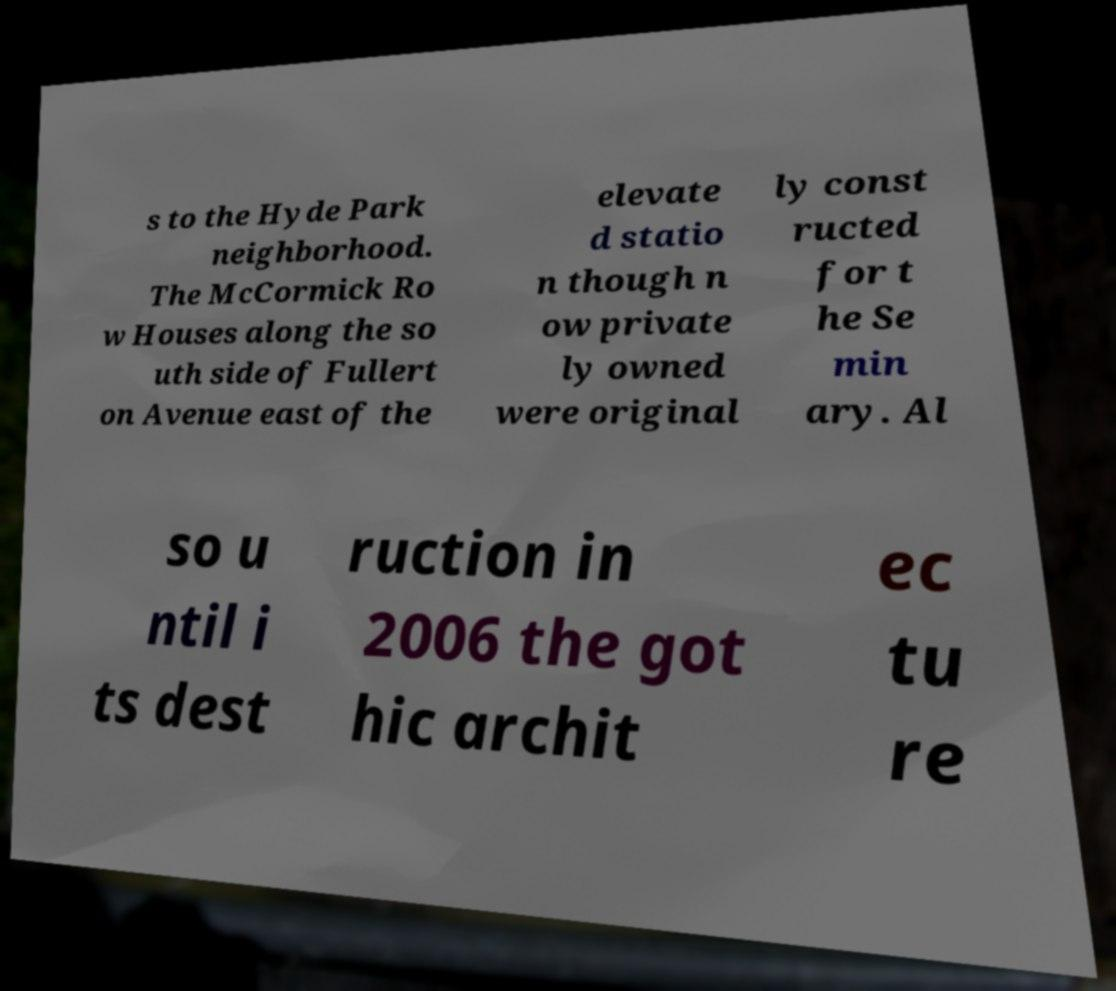What messages or text are displayed in this image? I need them in a readable, typed format. s to the Hyde Park neighborhood. The McCormick Ro w Houses along the so uth side of Fullert on Avenue east of the elevate d statio n though n ow private ly owned were original ly const ructed for t he Se min ary. Al so u ntil i ts dest ruction in 2006 the got hic archit ec tu re 